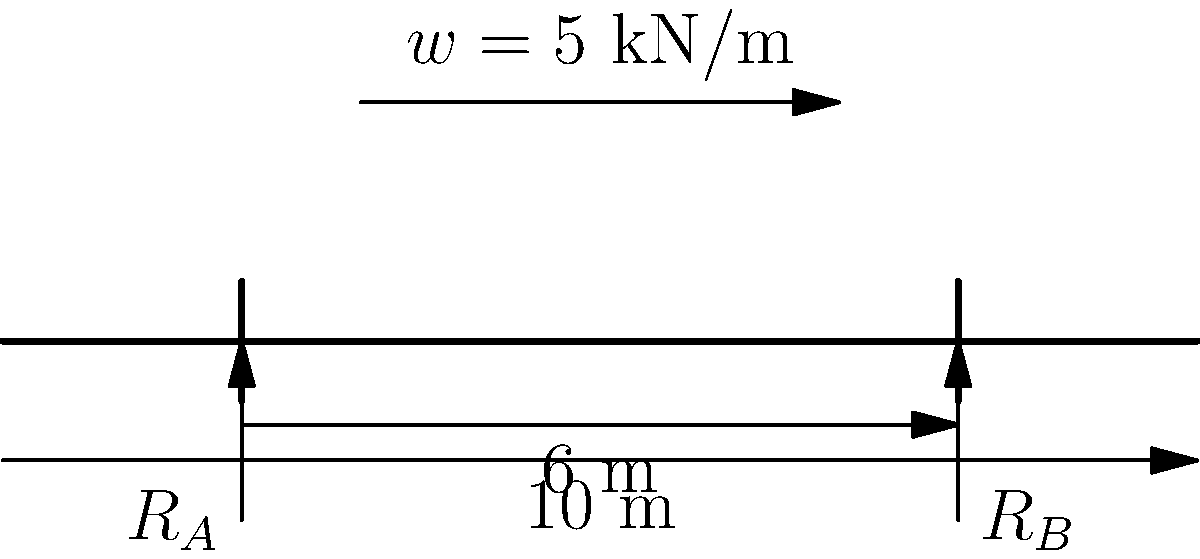Given the beam and load diagram shown above, determine the maximum bending moment in the beam. Assume the beam is simply supported at points A and B. To find the maximum bending moment, we'll follow these steps:

1) Calculate the total load:
   $W = w \times \text{length} = 5 \text{ kN/m} \times 4 \text{ m} = 20 \text{ kN}$

2) Find the reaction forces:
   Due to symmetry, $R_A = R_B = \frac{W}{2} = 10 \text{ kN}$

3) The maximum bending moment occurs at the center of the distributed load:
   Distance from A to center of load = $2 \text{ m} + 2 \text{ m} = 4 \text{ m}$

4) Calculate the maximum bending moment:
   $M_{max} = R_A \times 4 \text{ m} - \frac{w \times 2^2}{2}$
   
   $M_{max} = 10 \text{ kN} \times 4 \text{ m} - \frac{5 \text{ kN/m} \times 2^2 \text{ m}^2}{2}$
   
   $M_{max} = 40 \text{ kN·m} - 10 \text{ kN·m} = 30 \text{ kN·m}$

Therefore, the maximum bending moment in the beam is 30 kN·m.
Answer: 30 kN·m 